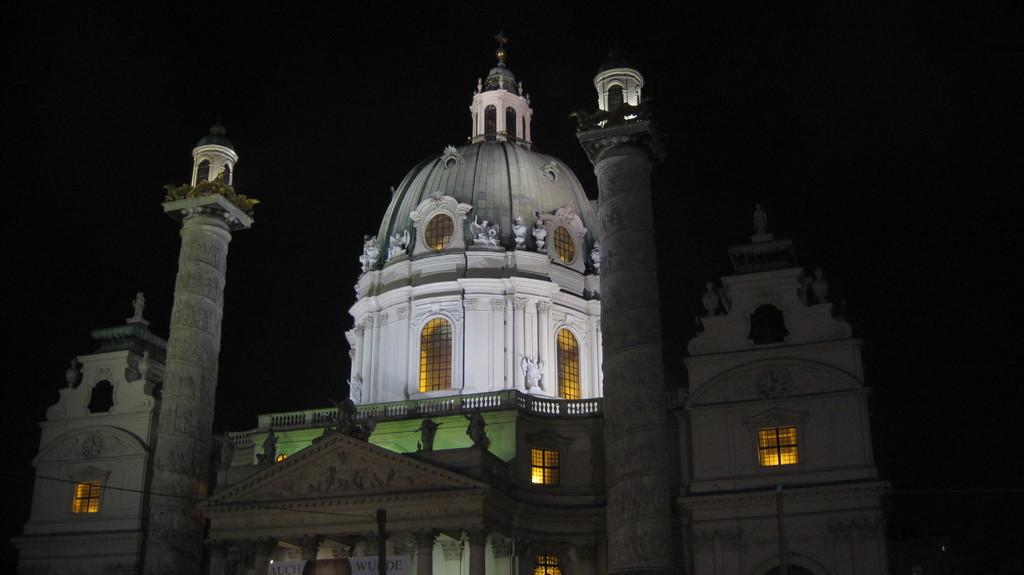What type of building is in the image? There is a white building in the image. What can be seen through the windows of the building? Lights are visible through the windows of the building. How would you describe the background of the image? The background of the image is dark. Is there any text or writing present in the image? Yes, there is text or writing visible in the image. What type of fruit is being used to slow down the white building in the image? There is no fruit present in the image, and therefore no such action can be observed. 